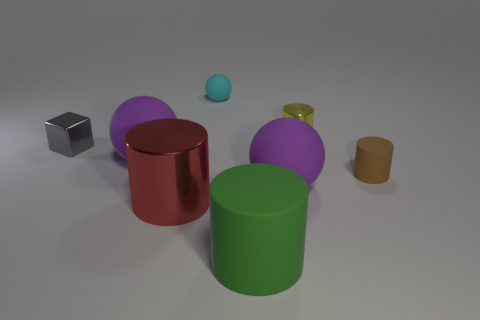Add 1 big objects. How many objects exist? 9 Subtract all blocks. How many objects are left? 7 Subtract 0 blue balls. How many objects are left? 8 Subtract all tiny cyan metallic spheres. Subtract all big green things. How many objects are left? 7 Add 8 brown things. How many brown things are left? 9 Add 4 small yellow metallic things. How many small yellow metallic things exist? 5 